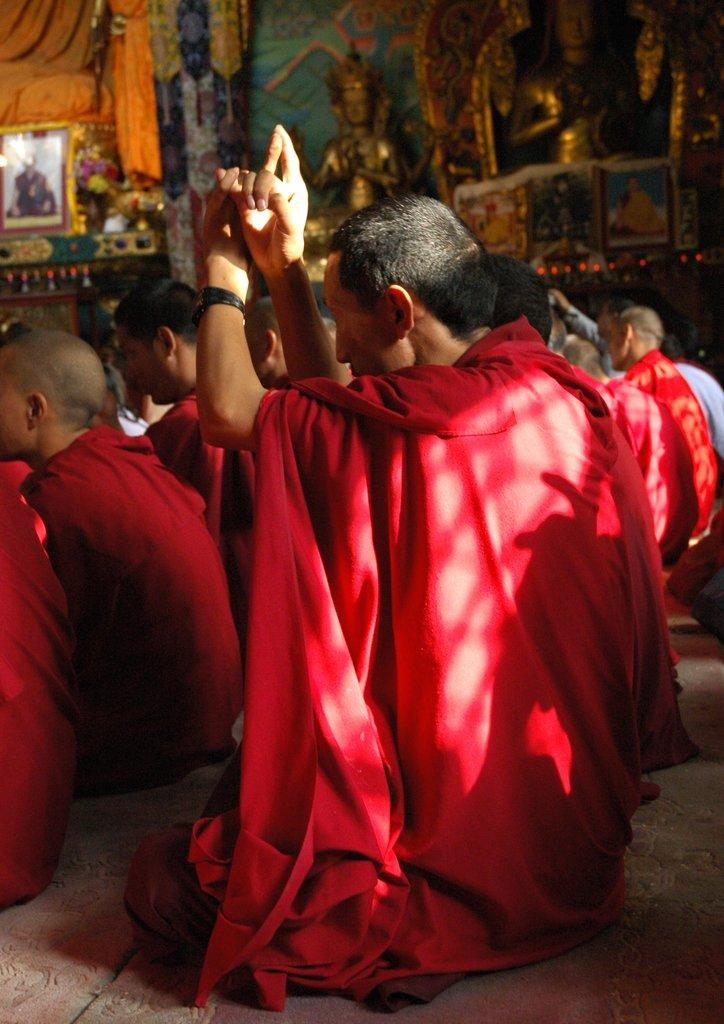What are the men in the image doing? The men in the image are sitting. What color clothes are the men wearing? The men are wearing red color clothes. Can you describe the setting or context of the image? The image is within a photo frame. What type of anger can be seen on the faces of the men in the image? There is no indication of anger on the faces of the men in the image. Can you tell me how many family members are present in the image? The provided facts do not mention any family members, so it cannot be determined from the image. 